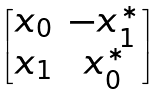Convert formula to latex. <formula><loc_0><loc_0><loc_500><loc_500>\begin{bmatrix} x _ { 0 } & - x _ { 1 } ^ { * } \\ x _ { 1 } & x _ { 0 } ^ { * } \end{bmatrix}</formula> 